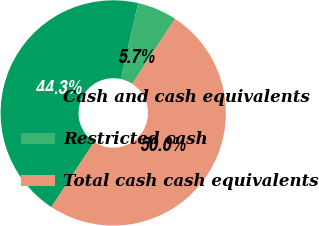<chart> <loc_0><loc_0><loc_500><loc_500><pie_chart><fcel>Cash and cash equivalents<fcel>Restricted cash<fcel>Total cash cash equivalents<nl><fcel>44.31%<fcel>5.69%<fcel>50.0%<nl></chart> 